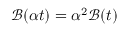<formula> <loc_0><loc_0><loc_500><loc_500>\mathcal { B } ( \alpha t ) = \alpha ^ { 2 } \mathcal { B } ( t )</formula> 